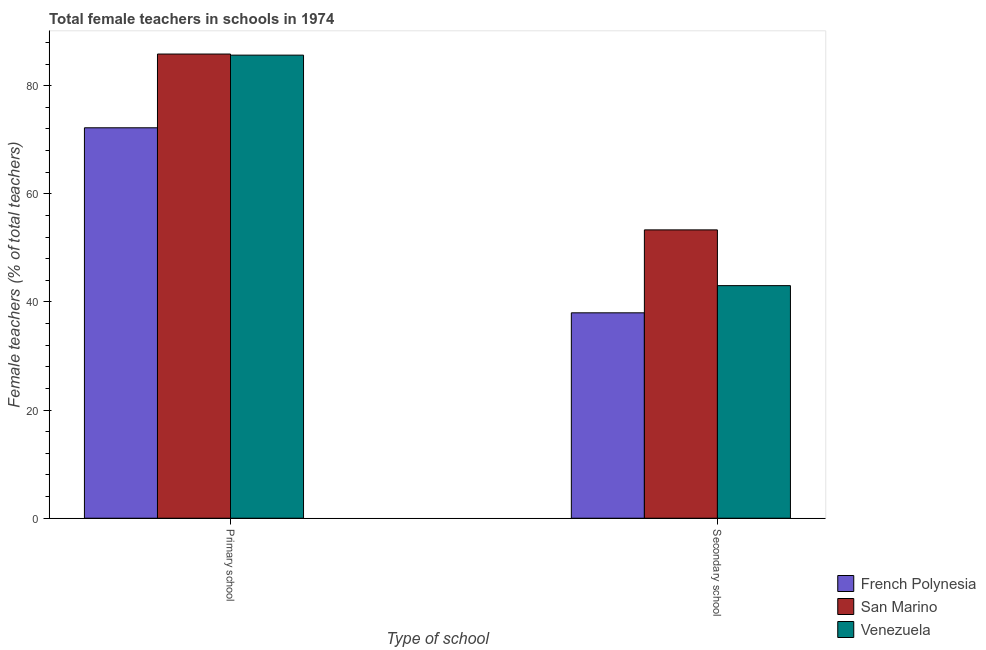How many different coloured bars are there?
Offer a very short reply. 3. Are the number of bars per tick equal to the number of legend labels?
Keep it short and to the point. Yes. How many bars are there on the 1st tick from the left?
Offer a very short reply. 3. How many bars are there on the 2nd tick from the right?
Offer a terse response. 3. What is the label of the 2nd group of bars from the left?
Give a very brief answer. Secondary school. What is the percentage of female teachers in primary schools in San Marino?
Ensure brevity in your answer.  85.86. Across all countries, what is the maximum percentage of female teachers in secondary schools?
Your answer should be compact. 53.33. Across all countries, what is the minimum percentage of female teachers in primary schools?
Make the answer very short. 72.22. In which country was the percentage of female teachers in secondary schools maximum?
Offer a terse response. San Marino. In which country was the percentage of female teachers in primary schools minimum?
Provide a succinct answer. French Polynesia. What is the total percentage of female teachers in primary schools in the graph?
Give a very brief answer. 243.73. What is the difference between the percentage of female teachers in primary schools in San Marino and that in French Polynesia?
Offer a terse response. 13.64. What is the difference between the percentage of female teachers in secondary schools in French Polynesia and the percentage of female teachers in primary schools in San Marino?
Keep it short and to the point. -47.87. What is the average percentage of female teachers in secondary schools per country?
Offer a very short reply. 44.78. What is the difference between the percentage of female teachers in secondary schools and percentage of female teachers in primary schools in French Polynesia?
Provide a succinct answer. -34.22. In how many countries, is the percentage of female teachers in secondary schools greater than 52 %?
Your answer should be compact. 1. What is the ratio of the percentage of female teachers in secondary schools in San Marino to that in Venezuela?
Your answer should be very brief. 1.24. In how many countries, is the percentage of female teachers in primary schools greater than the average percentage of female teachers in primary schools taken over all countries?
Make the answer very short. 2. What does the 2nd bar from the left in Secondary school represents?
Your answer should be very brief. San Marino. What does the 1st bar from the right in Secondary school represents?
Keep it short and to the point. Venezuela. How many bars are there?
Keep it short and to the point. 6. Are all the bars in the graph horizontal?
Keep it short and to the point. No. What is the difference between two consecutive major ticks on the Y-axis?
Ensure brevity in your answer.  20. Are the values on the major ticks of Y-axis written in scientific E-notation?
Keep it short and to the point. No. Where does the legend appear in the graph?
Offer a very short reply. Bottom right. How many legend labels are there?
Your response must be concise. 3. What is the title of the graph?
Provide a short and direct response. Total female teachers in schools in 1974. What is the label or title of the X-axis?
Provide a short and direct response. Type of school. What is the label or title of the Y-axis?
Your response must be concise. Female teachers (% of total teachers). What is the Female teachers (% of total teachers) of French Polynesia in Primary school?
Keep it short and to the point. 72.22. What is the Female teachers (% of total teachers) of San Marino in Primary school?
Ensure brevity in your answer.  85.86. What is the Female teachers (% of total teachers) of Venezuela in Primary school?
Offer a very short reply. 85.65. What is the Female teachers (% of total teachers) of French Polynesia in Secondary school?
Your answer should be compact. 37.99. What is the Female teachers (% of total teachers) in San Marino in Secondary school?
Provide a succinct answer. 53.33. What is the Female teachers (% of total teachers) in Venezuela in Secondary school?
Offer a very short reply. 43.02. Across all Type of school, what is the maximum Female teachers (% of total teachers) of French Polynesia?
Offer a terse response. 72.22. Across all Type of school, what is the maximum Female teachers (% of total teachers) in San Marino?
Make the answer very short. 85.86. Across all Type of school, what is the maximum Female teachers (% of total teachers) in Venezuela?
Give a very brief answer. 85.65. Across all Type of school, what is the minimum Female teachers (% of total teachers) in French Polynesia?
Your answer should be compact. 37.99. Across all Type of school, what is the minimum Female teachers (% of total teachers) in San Marino?
Your response must be concise. 53.33. Across all Type of school, what is the minimum Female teachers (% of total teachers) in Venezuela?
Your answer should be very brief. 43.02. What is the total Female teachers (% of total teachers) of French Polynesia in the graph?
Offer a terse response. 110.21. What is the total Female teachers (% of total teachers) of San Marino in the graph?
Provide a succinct answer. 139.19. What is the total Female teachers (% of total teachers) in Venezuela in the graph?
Offer a terse response. 128.68. What is the difference between the Female teachers (% of total teachers) in French Polynesia in Primary school and that in Secondary school?
Your answer should be very brief. 34.22. What is the difference between the Female teachers (% of total teachers) of San Marino in Primary school and that in Secondary school?
Ensure brevity in your answer.  32.53. What is the difference between the Female teachers (% of total teachers) of Venezuela in Primary school and that in Secondary school?
Your answer should be compact. 42.63. What is the difference between the Female teachers (% of total teachers) in French Polynesia in Primary school and the Female teachers (% of total teachers) in San Marino in Secondary school?
Ensure brevity in your answer.  18.88. What is the difference between the Female teachers (% of total teachers) in French Polynesia in Primary school and the Female teachers (% of total teachers) in Venezuela in Secondary school?
Ensure brevity in your answer.  29.2. What is the difference between the Female teachers (% of total teachers) in San Marino in Primary school and the Female teachers (% of total teachers) in Venezuela in Secondary school?
Offer a very short reply. 42.84. What is the average Female teachers (% of total teachers) of French Polynesia per Type of school?
Your answer should be very brief. 55.11. What is the average Female teachers (% of total teachers) of San Marino per Type of school?
Keep it short and to the point. 69.6. What is the average Female teachers (% of total teachers) in Venezuela per Type of school?
Give a very brief answer. 64.34. What is the difference between the Female teachers (% of total teachers) of French Polynesia and Female teachers (% of total teachers) of San Marino in Primary school?
Your answer should be compact. -13.64. What is the difference between the Female teachers (% of total teachers) in French Polynesia and Female teachers (% of total teachers) in Venezuela in Primary school?
Make the answer very short. -13.44. What is the difference between the Female teachers (% of total teachers) of San Marino and Female teachers (% of total teachers) of Venezuela in Primary school?
Your answer should be very brief. 0.2. What is the difference between the Female teachers (% of total teachers) in French Polynesia and Female teachers (% of total teachers) in San Marino in Secondary school?
Provide a succinct answer. -15.34. What is the difference between the Female teachers (% of total teachers) of French Polynesia and Female teachers (% of total teachers) of Venezuela in Secondary school?
Provide a short and direct response. -5.03. What is the difference between the Female teachers (% of total teachers) of San Marino and Female teachers (% of total teachers) of Venezuela in Secondary school?
Keep it short and to the point. 10.31. What is the ratio of the Female teachers (% of total teachers) in French Polynesia in Primary school to that in Secondary school?
Provide a succinct answer. 1.9. What is the ratio of the Female teachers (% of total teachers) in San Marino in Primary school to that in Secondary school?
Your response must be concise. 1.61. What is the ratio of the Female teachers (% of total teachers) of Venezuela in Primary school to that in Secondary school?
Keep it short and to the point. 1.99. What is the difference between the highest and the second highest Female teachers (% of total teachers) of French Polynesia?
Offer a very short reply. 34.22. What is the difference between the highest and the second highest Female teachers (% of total teachers) of San Marino?
Offer a terse response. 32.53. What is the difference between the highest and the second highest Female teachers (% of total teachers) of Venezuela?
Your response must be concise. 42.63. What is the difference between the highest and the lowest Female teachers (% of total teachers) in French Polynesia?
Keep it short and to the point. 34.22. What is the difference between the highest and the lowest Female teachers (% of total teachers) in San Marino?
Keep it short and to the point. 32.53. What is the difference between the highest and the lowest Female teachers (% of total teachers) of Venezuela?
Your answer should be very brief. 42.63. 